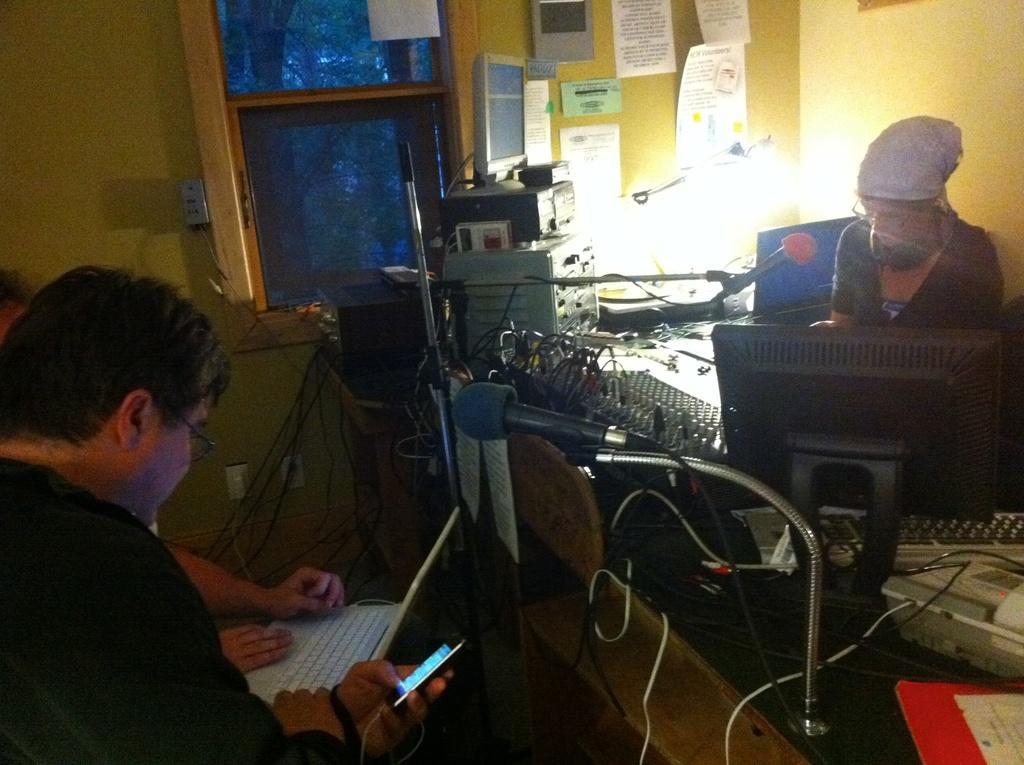Please provide a concise description of this image. This picture might be taken inside the room. In this image, on the left side, we can see people, one man is holding a laptop and another person is holding mobile in his hands. On the right side, we can see a table, on that table, we can see a microphone, monitor, keyboard, electric wires, land mobile, printers, we can also see a woman sitting on the chair in front of the table. In the background, we can see a wall with some papers, windows. 